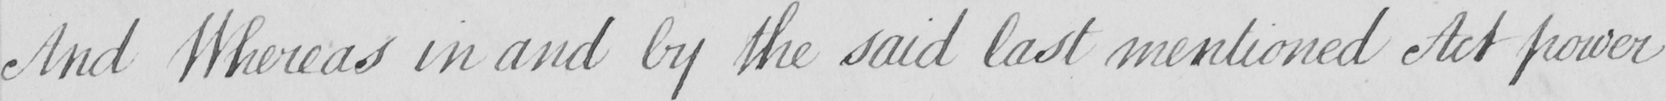Can you tell me what this handwritten text says? And Whereas in and by the said last mentioned Act power 